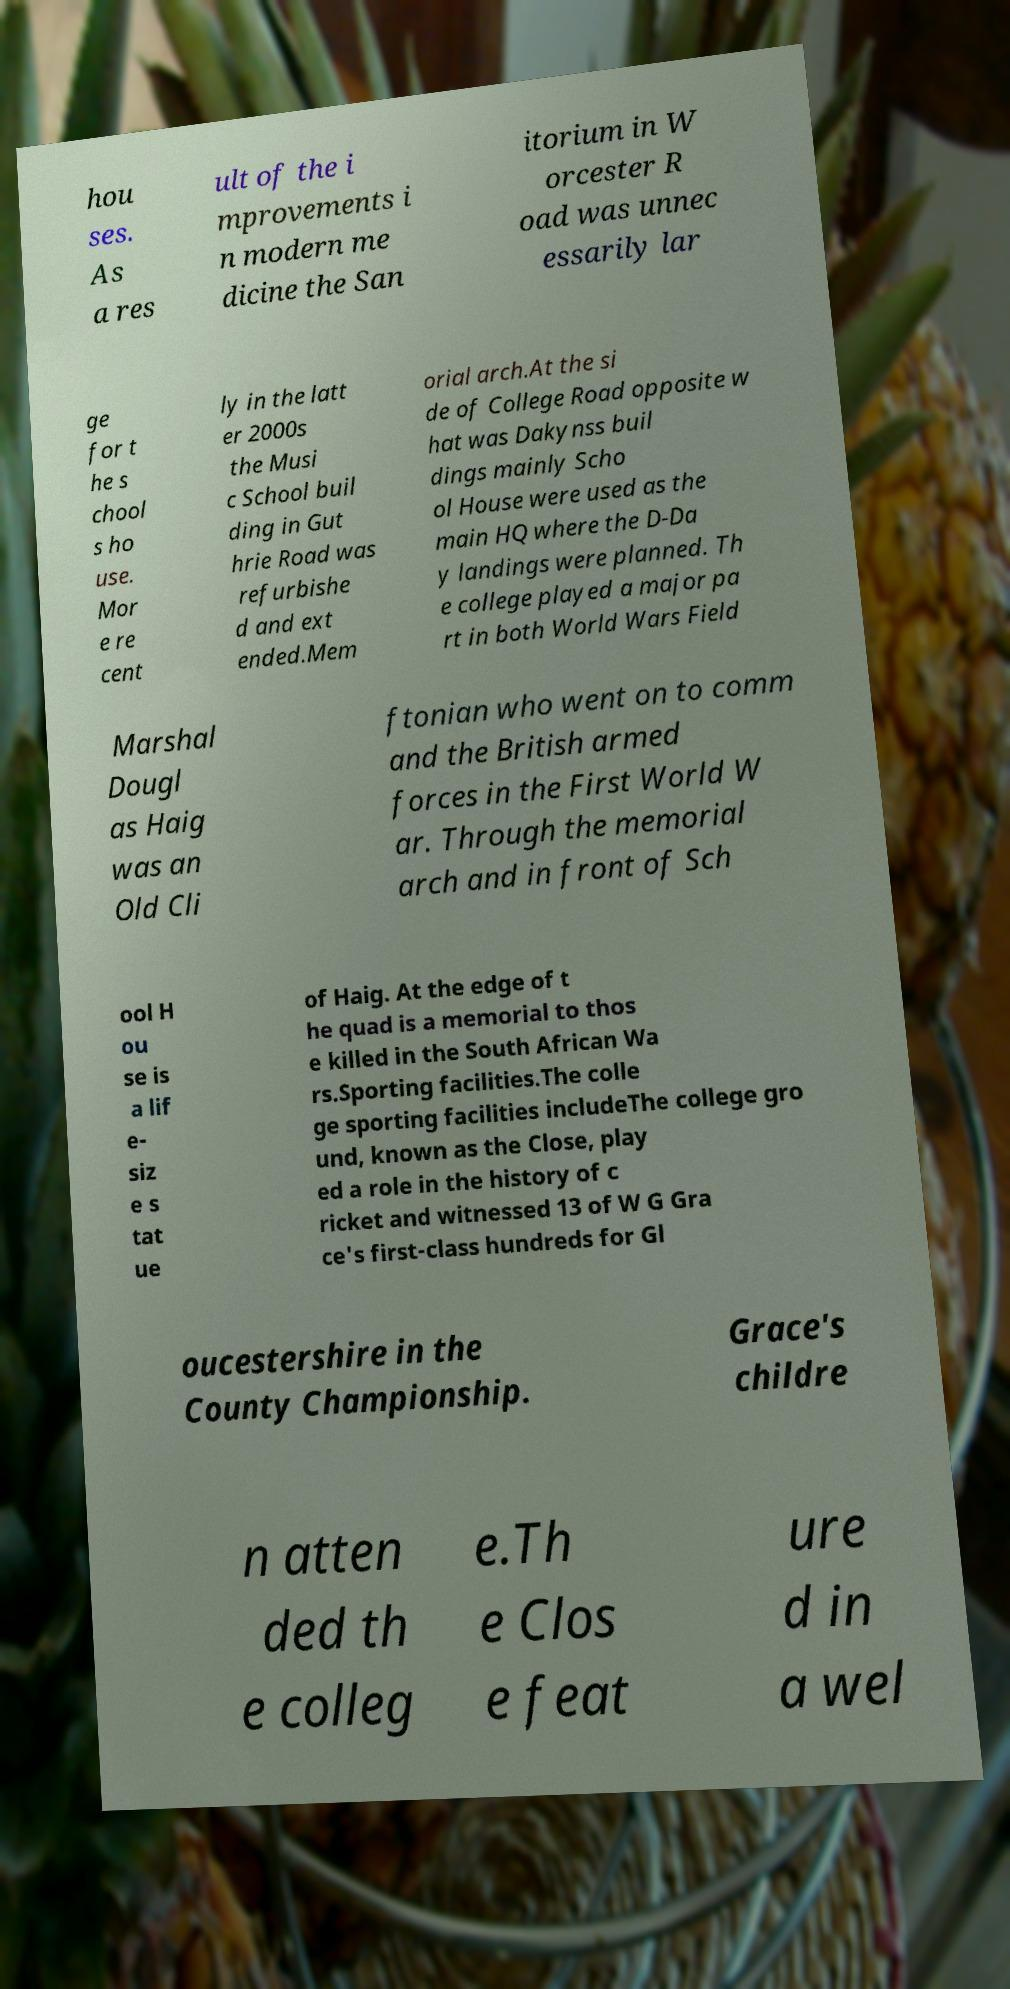Please read and relay the text visible in this image. What does it say? hou ses. As a res ult of the i mprovements i n modern me dicine the San itorium in W orcester R oad was unnec essarily lar ge for t he s chool s ho use. Mor e re cent ly in the latt er 2000s the Musi c School buil ding in Gut hrie Road was refurbishe d and ext ended.Mem orial arch.At the si de of College Road opposite w hat was Dakynss buil dings mainly Scho ol House were used as the main HQ where the D-Da y landings were planned. Th e college played a major pa rt in both World Wars Field Marshal Dougl as Haig was an Old Cli ftonian who went on to comm and the British armed forces in the First World W ar. Through the memorial arch and in front of Sch ool H ou se is a lif e- siz e s tat ue of Haig. At the edge of t he quad is a memorial to thos e killed in the South African Wa rs.Sporting facilities.The colle ge sporting facilities includeThe college gro und, known as the Close, play ed a role in the history of c ricket and witnessed 13 of W G Gra ce's first-class hundreds for Gl oucestershire in the County Championship. Grace's childre n atten ded th e colleg e.Th e Clos e feat ure d in a wel 